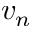<formula> <loc_0><loc_0><loc_500><loc_500>v _ { n }</formula> 